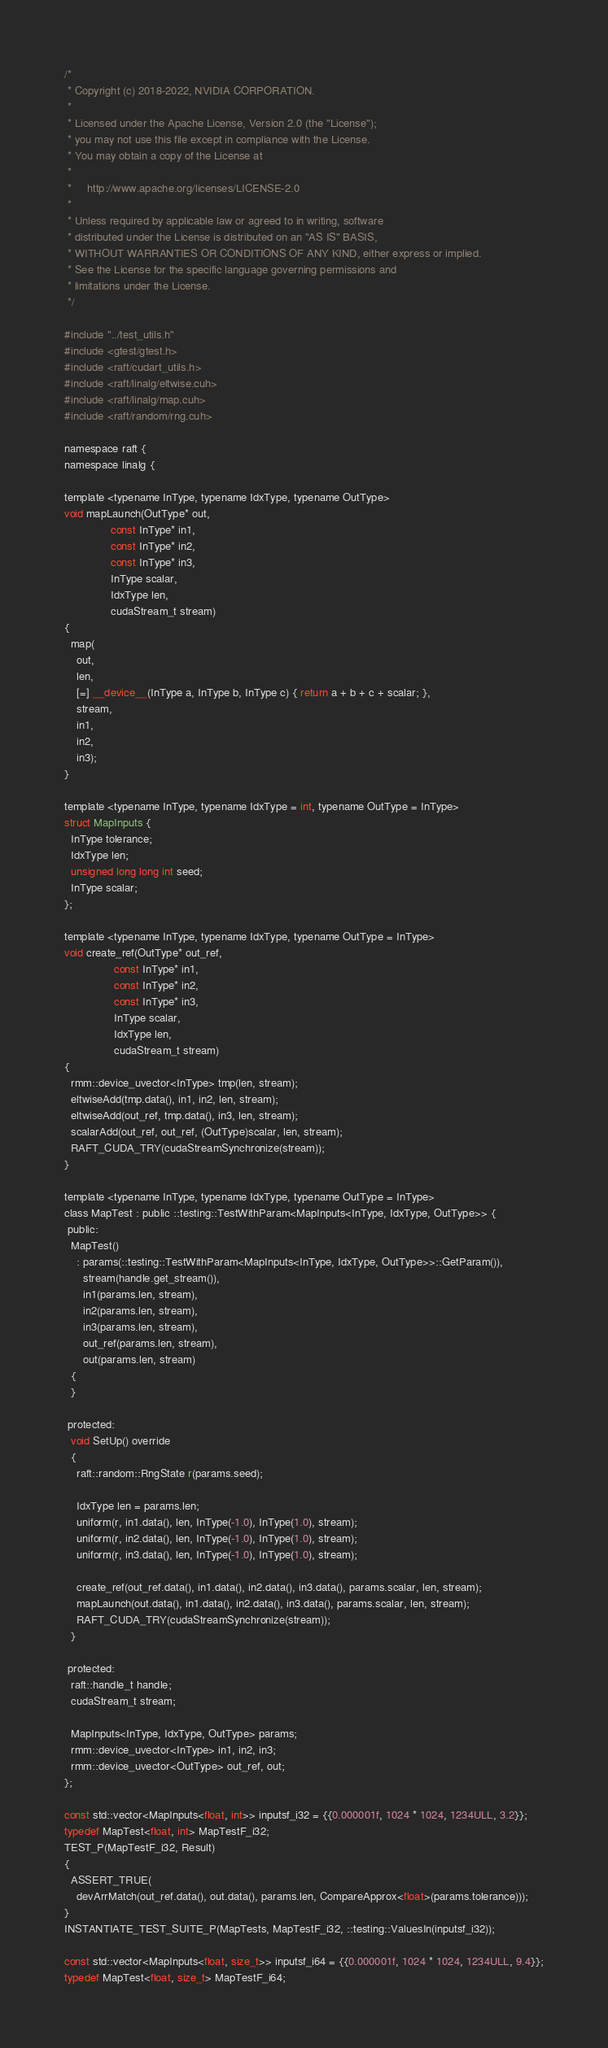<code> <loc_0><loc_0><loc_500><loc_500><_Cuda_>/*
 * Copyright (c) 2018-2022, NVIDIA CORPORATION.
 *
 * Licensed under the Apache License, Version 2.0 (the "License");
 * you may not use this file except in compliance with the License.
 * You may obtain a copy of the License at
 *
 *     http://www.apache.org/licenses/LICENSE-2.0
 *
 * Unless required by applicable law or agreed to in writing, software
 * distributed under the License is distributed on an "AS IS" BASIS,
 * WITHOUT WARRANTIES OR CONDITIONS OF ANY KIND, either express or implied.
 * See the License for the specific language governing permissions and
 * limitations under the License.
 */

#include "../test_utils.h"
#include <gtest/gtest.h>
#include <raft/cudart_utils.h>
#include <raft/linalg/eltwise.cuh>
#include <raft/linalg/map.cuh>
#include <raft/random/rng.cuh>

namespace raft {
namespace linalg {

template <typename InType, typename IdxType, typename OutType>
void mapLaunch(OutType* out,
               const InType* in1,
               const InType* in2,
               const InType* in3,
               InType scalar,
               IdxType len,
               cudaStream_t stream)
{
  map(
    out,
    len,
    [=] __device__(InType a, InType b, InType c) { return a + b + c + scalar; },
    stream,
    in1,
    in2,
    in3);
}

template <typename InType, typename IdxType = int, typename OutType = InType>
struct MapInputs {
  InType tolerance;
  IdxType len;
  unsigned long long int seed;
  InType scalar;
};

template <typename InType, typename IdxType, typename OutType = InType>
void create_ref(OutType* out_ref,
                const InType* in1,
                const InType* in2,
                const InType* in3,
                InType scalar,
                IdxType len,
                cudaStream_t stream)
{
  rmm::device_uvector<InType> tmp(len, stream);
  eltwiseAdd(tmp.data(), in1, in2, len, stream);
  eltwiseAdd(out_ref, tmp.data(), in3, len, stream);
  scalarAdd(out_ref, out_ref, (OutType)scalar, len, stream);
  RAFT_CUDA_TRY(cudaStreamSynchronize(stream));
}

template <typename InType, typename IdxType, typename OutType = InType>
class MapTest : public ::testing::TestWithParam<MapInputs<InType, IdxType, OutType>> {
 public:
  MapTest()
    : params(::testing::TestWithParam<MapInputs<InType, IdxType, OutType>>::GetParam()),
      stream(handle.get_stream()),
      in1(params.len, stream),
      in2(params.len, stream),
      in3(params.len, stream),
      out_ref(params.len, stream),
      out(params.len, stream)
  {
  }

 protected:
  void SetUp() override
  {
    raft::random::RngState r(params.seed);

    IdxType len = params.len;
    uniform(r, in1.data(), len, InType(-1.0), InType(1.0), stream);
    uniform(r, in2.data(), len, InType(-1.0), InType(1.0), stream);
    uniform(r, in3.data(), len, InType(-1.0), InType(1.0), stream);

    create_ref(out_ref.data(), in1.data(), in2.data(), in3.data(), params.scalar, len, stream);
    mapLaunch(out.data(), in1.data(), in2.data(), in3.data(), params.scalar, len, stream);
    RAFT_CUDA_TRY(cudaStreamSynchronize(stream));
  }

 protected:
  raft::handle_t handle;
  cudaStream_t stream;

  MapInputs<InType, IdxType, OutType> params;
  rmm::device_uvector<InType> in1, in2, in3;
  rmm::device_uvector<OutType> out_ref, out;
};

const std::vector<MapInputs<float, int>> inputsf_i32 = {{0.000001f, 1024 * 1024, 1234ULL, 3.2}};
typedef MapTest<float, int> MapTestF_i32;
TEST_P(MapTestF_i32, Result)
{
  ASSERT_TRUE(
    devArrMatch(out_ref.data(), out.data(), params.len, CompareApprox<float>(params.tolerance)));
}
INSTANTIATE_TEST_SUITE_P(MapTests, MapTestF_i32, ::testing::ValuesIn(inputsf_i32));

const std::vector<MapInputs<float, size_t>> inputsf_i64 = {{0.000001f, 1024 * 1024, 1234ULL, 9.4}};
typedef MapTest<float, size_t> MapTestF_i64;</code> 